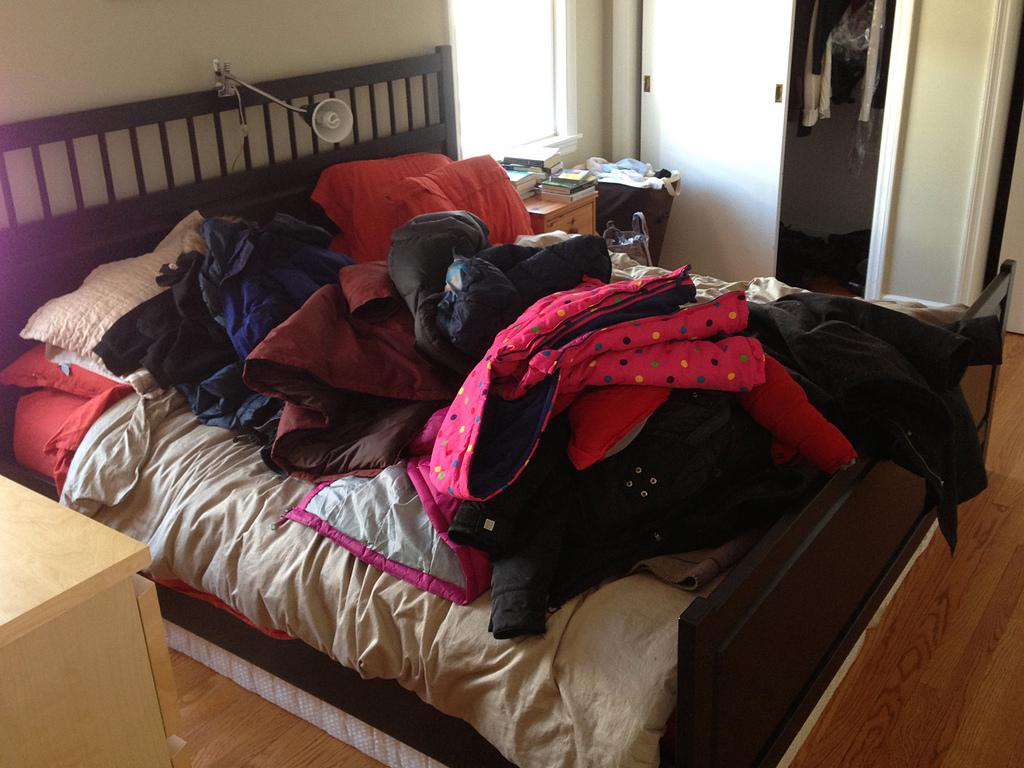Question: where is the pink jacket?
Choices:
A. On top of the pillows.
B. On top of the black jacket.
C. Under the yellow jacket.
D. On the bedpost.
Answer with the letter. Answer: B Question: what color is the wall?
Choices:
A. White.
B. Blue.
C. Yellow.
D. Green.
Answer with the letter. Answer: A Question: what is the floor made of?
Choices:
A. Wood.
B. Concrete.
C. Tiles.
D. Carpet.
Answer with the letter. Answer: A Question: how are the coats arranged on the bed?
Choices:
A. In small piles.
B. In large piles.
C. In a pile.
D. Spread out.
Answer with the letter. Answer: C Question: what color are the pillows?
Choices:
A. Orange.
B. Green.
C. Red.
D. Brown.
Answer with the letter. Answer: A Question: what color is the comforter?
Choices:
A. Red.
B. Blue.
C. White.
D. Tan.
Answer with the letter. Answer: D Question: what color is the coat on top of the pile?
Choices:
A. Green.
B. Blue.
C. Purple.
D. Pink.
Answer with the letter. Answer: D Question: what design is on the coat on top of the pile?
Choices:
A. Polka dots.
B. Chevron.
C. Stripes.
D. Floral.
Answer with the letter. Answer: A Question: what is attached to the headboard?
Choices:
A. A reading lamp.
B. Pomader.
C. Flashlight.
D. Bathrobe.
Answer with the letter. Answer: A Question: how clean is the room?
Choices:
A. It is dirty.
B. It is messy.
C. It is smelly.
D. It was just vacuumed.
Answer with the letter. Answer: B Question: how big is the bedroom?
Choices:
A. It is large.
B. It is small.
C. It is narrow.
D. It is average sized.
Answer with the letter. Answer: B Question: what furniture is in the room?
Choices:
A. A desk and a dresser.
B. A step stool and a ottoman.
C. A table and chair.
D. A bed and a nightstand.
Answer with the letter. Answer: D Question: why is the room sunlit?
Choices:
A. It has a skylight.
B. The curtains are open.
C. It has a window.
D. The blinds are open.
Answer with the letter. Answer: C Question: where is a light in this room?
Choices:
A. Clipped to the desk.
B. Clipped to the headboard.
C. Clipped to the ceiling.
D. Clipped to the wall.
Answer with the letter. Answer: B Question: what type of flooring is in the room?
Choices:
A. Hardwood.
B. Carpet.
C. Marble.
D. Porcelain.
Answer with the letter. Answer: A Question: how are the coats arranged on the bed?
Choices:
A. In a pile.
B. In a mess.
C. In a bag.
D. In a basket.
Answer with the letter. Answer: A Question: what color are the covers on the bed?
Choices:
A. Black.
B. Red.
C. Silver.
D. White.
Answer with the letter. Answer: D Question: what color is the bed frame?
Choices:
A. Black.
B. Tan.
C. White.
D. Gold.
Answer with the letter. Answer: A Question: how are the books arranged?
Choices:
A. In a row.
B. On a case.
C. In a pile.
D. On the table.
Answer with the letter. Answer: C Question: what is shining through the window?
Choices:
A. A light.
B. Sunlight.
C. The moon.
D. The stars.
Answer with the letter. Answer: B Question: what material is the dresser made of?
Choices:
A. Plastic.
B. Wood.
C. Pressed wood.
D. Cardboard.
Answer with the letter. Answer: B Question: how is the light during the daytime?
Choices:
A. Turned on in bad weather.
B. Turned off.
C. Dimmed.
D. On.
Answer with the letter. Answer: B Question: what are the boxsprings placed on?
Choices:
A. The floor.
B. In the closet.
C. No where.
D. The frame.
Answer with the letter. Answer: D Question: what has a swirl shaped light bulb?
Choices:
A. A side table lamp.
B. A vanity lamp.
C. A kitchen light.
D. Reading lamp.
Answer with the letter. Answer: D Question: what color is the dresser?
Choices:
A. Mauve.
B. Red.
C. Light tan.
D. Black.
Answer with the letter. Answer: C 